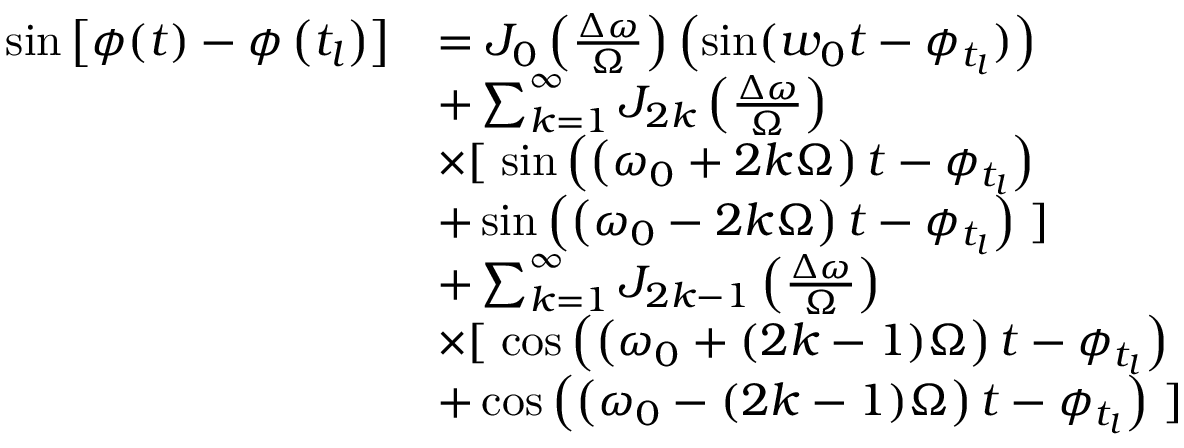Convert formula to latex. <formula><loc_0><loc_0><loc_500><loc_500>\begin{array} { r l } { \sin \left [ \phi ( t ) - \phi \left ( t _ { l } \right ) \right ] } & { = J _ { 0 } \left ( \frac { \Delta \omega } { \Omega } \right ) \left ( \sin ( w _ { 0 } t - \phi _ { t _ { l } } ) \right ) } \\ & { + \sum _ { k = 1 } ^ { \infty } J _ { 2 k } \left ( \frac { \Delta \omega } { \Omega } \right ) } \\ & { \times [ \, \sin \left ( \left ( \omega _ { 0 } + 2 k \Omega \right ) t - \phi _ { t _ { l } } \right ) } \\ & { + \sin \left ( \left ( \omega _ { 0 } - 2 k \Omega \right ) t - \phi _ { t _ { l } } \right ) \, ] } \\ & { + \sum _ { k = 1 } ^ { \infty } J _ { 2 k - 1 } \left ( \frac { \Delta \omega } { \Omega } \right ) } \\ & { \times [ \, \cos \left ( \left ( \omega _ { 0 } + ( 2 k - 1 ) \Omega \right ) t - \phi _ { t _ { l } } \right ) } \\ & { + \cos \left ( \left ( \omega _ { 0 } - ( 2 k - 1 ) \Omega \right ) t - \phi _ { t _ { l } } \right ) \, ] } \end{array}</formula> 